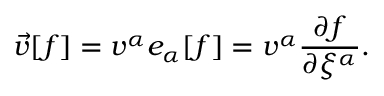Convert formula to latex. <formula><loc_0><loc_0><loc_500><loc_500>\vec { v } [ f ] = v ^ { \alpha } e _ { \alpha } [ f ] = v ^ { \alpha } \frac { \partial f } { \partial \xi ^ { \alpha } } .</formula> 